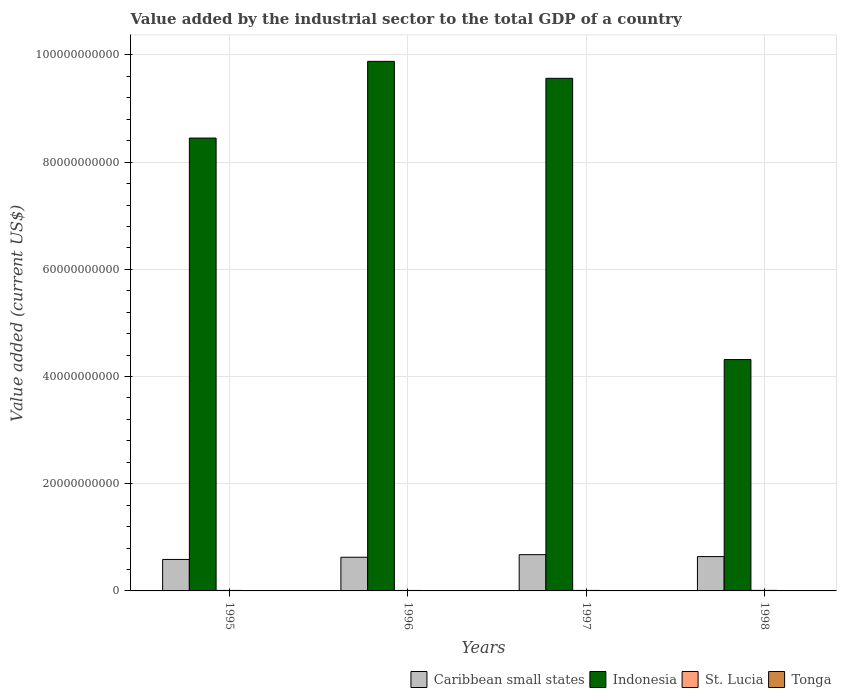Are the number of bars per tick equal to the number of legend labels?
Your response must be concise. Yes. How many bars are there on the 2nd tick from the left?
Make the answer very short. 4. How many bars are there on the 1st tick from the right?
Your answer should be compact. 4. What is the value added by the industrial sector to the total GDP in Indonesia in 1996?
Offer a very short reply. 9.88e+1. Across all years, what is the maximum value added by the industrial sector to the total GDP in Caribbean small states?
Keep it short and to the point. 6.76e+09. Across all years, what is the minimum value added by the industrial sector to the total GDP in St. Lucia?
Give a very brief answer. 9.03e+07. In which year was the value added by the industrial sector to the total GDP in Indonesia maximum?
Give a very brief answer. 1996. In which year was the value added by the industrial sector to the total GDP in Caribbean small states minimum?
Provide a succinct answer. 1995. What is the total value added by the industrial sector to the total GDP in Indonesia in the graph?
Ensure brevity in your answer.  3.22e+11. What is the difference between the value added by the industrial sector to the total GDP in Caribbean small states in 1996 and that in 1997?
Give a very brief answer. -4.80e+08. What is the difference between the value added by the industrial sector to the total GDP in Caribbean small states in 1996 and the value added by the industrial sector to the total GDP in St. Lucia in 1995?
Provide a short and direct response. 6.19e+09. What is the average value added by the industrial sector to the total GDP in St. Lucia per year?
Your answer should be compact. 9.35e+07. In the year 1998, what is the difference between the value added by the industrial sector to the total GDP in Indonesia and value added by the industrial sector to the total GDP in St. Lucia?
Your response must be concise. 4.31e+1. In how many years, is the value added by the industrial sector to the total GDP in Tonga greater than 20000000000 US$?
Ensure brevity in your answer.  0. What is the ratio of the value added by the industrial sector to the total GDP in St. Lucia in 1995 to that in 1997?
Offer a very short reply. 1.02. Is the value added by the industrial sector to the total GDP in Tonga in 1995 less than that in 1998?
Provide a succinct answer. No. Is the difference between the value added by the industrial sector to the total GDP in Indonesia in 1995 and 1998 greater than the difference between the value added by the industrial sector to the total GDP in St. Lucia in 1995 and 1998?
Your answer should be very brief. Yes. What is the difference between the highest and the second highest value added by the industrial sector to the total GDP in Caribbean small states?
Your answer should be very brief. 3.56e+08. What is the difference between the highest and the lowest value added by the industrial sector to the total GDP in Tonga?
Ensure brevity in your answer.  1.06e+07. Is it the case that in every year, the sum of the value added by the industrial sector to the total GDP in Tonga and value added by the industrial sector to the total GDP in Indonesia is greater than the sum of value added by the industrial sector to the total GDP in Caribbean small states and value added by the industrial sector to the total GDP in St. Lucia?
Your response must be concise. Yes. What does the 3rd bar from the left in 1996 represents?
Offer a very short reply. St. Lucia. What does the 1st bar from the right in 1995 represents?
Provide a short and direct response. Tonga. Is it the case that in every year, the sum of the value added by the industrial sector to the total GDP in Indonesia and value added by the industrial sector to the total GDP in Tonga is greater than the value added by the industrial sector to the total GDP in St. Lucia?
Ensure brevity in your answer.  Yes. How many bars are there?
Provide a succinct answer. 16. Are all the bars in the graph horizontal?
Ensure brevity in your answer.  No. What is the difference between two consecutive major ticks on the Y-axis?
Offer a very short reply. 2.00e+1. Does the graph contain grids?
Offer a terse response. Yes. How many legend labels are there?
Your answer should be very brief. 4. What is the title of the graph?
Provide a succinct answer. Value added by the industrial sector to the total GDP of a country. Does "Cabo Verde" appear as one of the legend labels in the graph?
Provide a succinct answer. No. What is the label or title of the X-axis?
Ensure brevity in your answer.  Years. What is the label or title of the Y-axis?
Provide a short and direct response. Value added (current US$). What is the Value added (current US$) of Caribbean small states in 1995?
Offer a terse response. 5.87e+09. What is the Value added (current US$) in Indonesia in 1995?
Your answer should be compact. 8.45e+1. What is the Value added (current US$) of St. Lucia in 1995?
Give a very brief answer. 9.26e+07. What is the Value added (current US$) of Tonga in 1995?
Offer a terse response. 3.95e+07. What is the Value added (current US$) of Caribbean small states in 1996?
Provide a succinct answer. 6.28e+09. What is the Value added (current US$) of Indonesia in 1996?
Offer a terse response. 9.88e+1. What is the Value added (current US$) of St. Lucia in 1996?
Your answer should be compact. 9.03e+07. What is the Value added (current US$) of Tonga in 1996?
Keep it short and to the point. 4.25e+07. What is the Value added (current US$) in Caribbean small states in 1997?
Your response must be concise. 6.76e+09. What is the Value added (current US$) in Indonesia in 1997?
Offer a very short reply. 9.56e+1. What is the Value added (current US$) in St. Lucia in 1997?
Give a very brief answer. 9.10e+07. What is the Value added (current US$) of Tonga in 1997?
Your response must be concise. 3.64e+07. What is the Value added (current US$) of Caribbean small states in 1998?
Offer a very short reply. 6.41e+09. What is the Value added (current US$) in Indonesia in 1998?
Give a very brief answer. 4.32e+1. What is the Value added (current US$) in St. Lucia in 1998?
Your answer should be very brief. 1.00e+08. What is the Value added (current US$) in Tonga in 1998?
Your answer should be compact. 3.18e+07. Across all years, what is the maximum Value added (current US$) of Caribbean small states?
Your answer should be compact. 6.76e+09. Across all years, what is the maximum Value added (current US$) in Indonesia?
Give a very brief answer. 9.88e+1. Across all years, what is the maximum Value added (current US$) of St. Lucia?
Provide a short and direct response. 1.00e+08. Across all years, what is the maximum Value added (current US$) of Tonga?
Your answer should be very brief. 4.25e+07. Across all years, what is the minimum Value added (current US$) in Caribbean small states?
Provide a succinct answer. 5.87e+09. Across all years, what is the minimum Value added (current US$) of Indonesia?
Ensure brevity in your answer.  4.32e+1. Across all years, what is the minimum Value added (current US$) in St. Lucia?
Give a very brief answer. 9.03e+07. Across all years, what is the minimum Value added (current US$) in Tonga?
Ensure brevity in your answer.  3.18e+07. What is the total Value added (current US$) in Caribbean small states in the graph?
Provide a short and direct response. 2.53e+1. What is the total Value added (current US$) in Indonesia in the graph?
Give a very brief answer. 3.22e+11. What is the total Value added (current US$) in St. Lucia in the graph?
Your response must be concise. 3.74e+08. What is the total Value added (current US$) in Tonga in the graph?
Keep it short and to the point. 1.50e+08. What is the difference between the Value added (current US$) in Caribbean small states in 1995 and that in 1996?
Your answer should be compact. -4.11e+08. What is the difference between the Value added (current US$) in Indonesia in 1995 and that in 1996?
Provide a succinct answer. -1.43e+1. What is the difference between the Value added (current US$) in St. Lucia in 1995 and that in 1996?
Provide a short and direct response. 2.36e+06. What is the difference between the Value added (current US$) in Tonga in 1995 and that in 1996?
Provide a short and direct response. -2.95e+06. What is the difference between the Value added (current US$) in Caribbean small states in 1995 and that in 1997?
Make the answer very short. -8.90e+08. What is the difference between the Value added (current US$) of Indonesia in 1995 and that in 1997?
Offer a terse response. -1.11e+1. What is the difference between the Value added (current US$) of St. Lucia in 1995 and that in 1997?
Provide a succinct answer. 1.59e+06. What is the difference between the Value added (current US$) in Tonga in 1995 and that in 1997?
Provide a succinct answer. 3.13e+06. What is the difference between the Value added (current US$) in Caribbean small states in 1995 and that in 1998?
Offer a very short reply. -5.34e+08. What is the difference between the Value added (current US$) in Indonesia in 1995 and that in 1998?
Offer a very short reply. 4.13e+1. What is the difference between the Value added (current US$) in St. Lucia in 1995 and that in 1998?
Keep it short and to the point. -7.36e+06. What is the difference between the Value added (current US$) in Tonga in 1995 and that in 1998?
Offer a terse response. 7.68e+06. What is the difference between the Value added (current US$) of Caribbean small states in 1996 and that in 1997?
Your answer should be very brief. -4.80e+08. What is the difference between the Value added (current US$) in Indonesia in 1996 and that in 1997?
Make the answer very short. 3.17e+09. What is the difference between the Value added (current US$) in St. Lucia in 1996 and that in 1997?
Make the answer very short. -7.78e+05. What is the difference between the Value added (current US$) of Tonga in 1996 and that in 1997?
Make the answer very short. 6.08e+06. What is the difference between the Value added (current US$) of Caribbean small states in 1996 and that in 1998?
Provide a succinct answer. -1.24e+08. What is the difference between the Value added (current US$) in Indonesia in 1996 and that in 1998?
Your answer should be compact. 5.56e+1. What is the difference between the Value added (current US$) in St. Lucia in 1996 and that in 1998?
Keep it short and to the point. -9.73e+06. What is the difference between the Value added (current US$) of Tonga in 1996 and that in 1998?
Offer a very short reply. 1.06e+07. What is the difference between the Value added (current US$) of Caribbean small states in 1997 and that in 1998?
Your response must be concise. 3.56e+08. What is the difference between the Value added (current US$) in Indonesia in 1997 and that in 1998?
Ensure brevity in your answer.  5.25e+1. What is the difference between the Value added (current US$) of St. Lucia in 1997 and that in 1998?
Ensure brevity in your answer.  -8.95e+06. What is the difference between the Value added (current US$) in Tonga in 1997 and that in 1998?
Provide a short and direct response. 4.55e+06. What is the difference between the Value added (current US$) in Caribbean small states in 1995 and the Value added (current US$) in Indonesia in 1996?
Give a very brief answer. -9.29e+1. What is the difference between the Value added (current US$) in Caribbean small states in 1995 and the Value added (current US$) in St. Lucia in 1996?
Keep it short and to the point. 5.78e+09. What is the difference between the Value added (current US$) of Caribbean small states in 1995 and the Value added (current US$) of Tonga in 1996?
Your answer should be compact. 5.83e+09. What is the difference between the Value added (current US$) of Indonesia in 1995 and the Value added (current US$) of St. Lucia in 1996?
Offer a very short reply. 8.44e+1. What is the difference between the Value added (current US$) of Indonesia in 1995 and the Value added (current US$) of Tonga in 1996?
Your answer should be very brief. 8.45e+1. What is the difference between the Value added (current US$) of St. Lucia in 1995 and the Value added (current US$) of Tonga in 1996?
Keep it short and to the point. 5.02e+07. What is the difference between the Value added (current US$) in Caribbean small states in 1995 and the Value added (current US$) in Indonesia in 1997?
Your response must be concise. -8.98e+1. What is the difference between the Value added (current US$) in Caribbean small states in 1995 and the Value added (current US$) in St. Lucia in 1997?
Your response must be concise. 5.78e+09. What is the difference between the Value added (current US$) in Caribbean small states in 1995 and the Value added (current US$) in Tonga in 1997?
Provide a short and direct response. 5.84e+09. What is the difference between the Value added (current US$) in Indonesia in 1995 and the Value added (current US$) in St. Lucia in 1997?
Keep it short and to the point. 8.44e+1. What is the difference between the Value added (current US$) in Indonesia in 1995 and the Value added (current US$) in Tonga in 1997?
Make the answer very short. 8.45e+1. What is the difference between the Value added (current US$) of St. Lucia in 1995 and the Value added (current US$) of Tonga in 1997?
Provide a succinct answer. 5.63e+07. What is the difference between the Value added (current US$) in Caribbean small states in 1995 and the Value added (current US$) in Indonesia in 1998?
Make the answer very short. -3.73e+1. What is the difference between the Value added (current US$) in Caribbean small states in 1995 and the Value added (current US$) in St. Lucia in 1998?
Provide a short and direct response. 5.77e+09. What is the difference between the Value added (current US$) in Caribbean small states in 1995 and the Value added (current US$) in Tonga in 1998?
Your answer should be compact. 5.84e+09. What is the difference between the Value added (current US$) in Indonesia in 1995 and the Value added (current US$) in St. Lucia in 1998?
Offer a terse response. 8.44e+1. What is the difference between the Value added (current US$) in Indonesia in 1995 and the Value added (current US$) in Tonga in 1998?
Your answer should be very brief. 8.45e+1. What is the difference between the Value added (current US$) of St. Lucia in 1995 and the Value added (current US$) of Tonga in 1998?
Provide a short and direct response. 6.08e+07. What is the difference between the Value added (current US$) of Caribbean small states in 1996 and the Value added (current US$) of Indonesia in 1997?
Your answer should be very brief. -8.94e+1. What is the difference between the Value added (current US$) of Caribbean small states in 1996 and the Value added (current US$) of St. Lucia in 1997?
Your answer should be very brief. 6.19e+09. What is the difference between the Value added (current US$) in Caribbean small states in 1996 and the Value added (current US$) in Tonga in 1997?
Your answer should be compact. 6.25e+09. What is the difference between the Value added (current US$) in Indonesia in 1996 and the Value added (current US$) in St. Lucia in 1997?
Your answer should be very brief. 9.87e+1. What is the difference between the Value added (current US$) in Indonesia in 1996 and the Value added (current US$) in Tonga in 1997?
Your answer should be compact. 9.88e+1. What is the difference between the Value added (current US$) of St. Lucia in 1996 and the Value added (current US$) of Tonga in 1997?
Make the answer very short. 5.39e+07. What is the difference between the Value added (current US$) in Caribbean small states in 1996 and the Value added (current US$) in Indonesia in 1998?
Give a very brief answer. -3.69e+1. What is the difference between the Value added (current US$) of Caribbean small states in 1996 and the Value added (current US$) of St. Lucia in 1998?
Keep it short and to the point. 6.18e+09. What is the difference between the Value added (current US$) in Caribbean small states in 1996 and the Value added (current US$) in Tonga in 1998?
Make the answer very short. 6.25e+09. What is the difference between the Value added (current US$) in Indonesia in 1996 and the Value added (current US$) in St. Lucia in 1998?
Make the answer very short. 9.87e+1. What is the difference between the Value added (current US$) in Indonesia in 1996 and the Value added (current US$) in Tonga in 1998?
Offer a terse response. 9.88e+1. What is the difference between the Value added (current US$) of St. Lucia in 1996 and the Value added (current US$) of Tonga in 1998?
Ensure brevity in your answer.  5.84e+07. What is the difference between the Value added (current US$) in Caribbean small states in 1997 and the Value added (current US$) in Indonesia in 1998?
Keep it short and to the point. -3.64e+1. What is the difference between the Value added (current US$) of Caribbean small states in 1997 and the Value added (current US$) of St. Lucia in 1998?
Keep it short and to the point. 6.66e+09. What is the difference between the Value added (current US$) in Caribbean small states in 1997 and the Value added (current US$) in Tonga in 1998?
Ensure brevity in your answer.  6.73e+09. What is the difference between the Value added (current US$) of Indonesia in 1997 and the Value added (current US$) of St. Lucia in 1998?
Provide a succinct answer. 9.55e+1. What is the difference between the Value added (current US$) in Indonesia in 1997 and the Value added (current US$) in Tonga in 1998?
Your response must be concise. 9.56e+1. What is the difference between the Value added (current US$) in St. Lucia in 1997 and the Value added (current US$) in Tonga in 1998?
Keep it short and to the point. 5.92e+07. What is the average Value added (current US$) of Caribbean small states per year?
Ensure brevity in your answer.  6.33e+09. What is the average Value added (current US$) in Indonesia per year?
Offer a very short reply. 8.05e+1. What is the average Value added (current US$) in St. Lucia per year?
Your answer should be very brief. 9.35e+07. What is the average Value added (current US$) in Tonga per year?
Provide a short and direct response. 3.75e+07. In the year 1995, what is the difference between the Value added (current US$) of Caribbean small states and Value added (current US$) of Indonesia?
Your answer should be compact. -7.86e+1. In the year 1995, what is the difference between the Value added (current US$) of Caribbean small states and Value added (current US$) of St. Lucia?
Your answer should be compact. 5.78e+09. In the year 1995, what is the difference between the Value added (current US$) of Caribbean small states and Value added (current US$) of Tonga?
Give a very brief answer. 5.83e+09. In the year 1995, what is the difference between the Value added (current US$) of Indonesia and Value added (current US$) of St. Lucia?
Give a very brief answer. 8.44e+1. In the year 1995, what is the difference between the Value added (current US$) of Indonesia and Value added (current US$) of Tonga?
Provide a succinct answer. 8.45e+1. In the year 1995, what is the difference between the Value added (current US$) in St. Lucia and Value added (current US$) in Tonga?
Your answer should be very brief. 5.31e+07. In the year 1996, what is the difference between the Value added (current US$) of Caribbean small states and Value added (current US$) of Indonesia?
Offer a terse response. -9.25e+1. In the year 1996, what is the difference between the Value added (current US$) of Caribbean small states and Value added (current US$) of St. Lucia?
Provide a short and direct response. 6.19e+09. In the year 1996, what is the difference between the Value added (current US$) in Caribbean small states and Value added (current US$) in Tonga?
Give a very brief answer. 6.24e+09. In the year 1996, what is the difference between the Value added (current US$) of Indonesia and Value added (current US$) of St. Lucia?
Provide a short and direct response. 9.87e+1. In the year 1996, what is the difference between the Value added (current US$) of Indonesia and Value added (current US$) of Tonga?
Give a very brief answer. 9.88e+1. In the year 1996, what is the difference between the Value added (current US$) of St. Lucia and Value added (current US$) of Tonga?
Keep it short and to the point. 4.78e+07. In the year 1997, what is the difference between the Value added (current US$) of Caribbean small states and Value added (current US$) of Indonesia?
Give a very brief answer. -8.89e+1. In the year 1997, what is the difference between the Value added (current US$) of Caribbean small states and Value added (current US$) of St. Lucia?
Make the answer very short. 6.67e+09. In the year 1997, what is the difference between the Value added (current US$) in Caribbean small states and Value added (current US$) in Tonga?
Keep it short and to the point. 6.73e+09. In the year 1997, what is the difference between the Value added (current US$) in Indonesia and Value added (current US$) in St. Lucia?
Keep it short and to the point. 9.55e+1. In the year 1997, what is the difference between the Value added (current US$) in Indonesia and Value added (current US$) in Tonga?
Make the answer very short. 9.56e+1. In the year 1997, what is the difference between the Value added (current US$) in St. Lucia and Value added (current US$) in Tonga?
Make the answer very short. 5.47e+07. In the year 1998, what is the difference between the Value added (current US$) of Caribbean small states and Value added (current US$) of Indonesia?
Your answer should be compact. -3.68e+1. In the year 1998, what is the difference between the Value added (current US$) in Caribbean small states and Value added (current US$) in St. Lucia?
Make the answer very short. 6.31e+09. In the year 1998, what is the difference between the Value added (current US$) of Caribbean small states and Value added (current US$) of Tonga?
Keep it short and to the point. 6.38e+09. In the year 1998, what is the difference between the Value added (current US$) of Indonesia and Value added (current US$) of St. Lucia?
Give a very brief answer. 4.31e+1. In the year 1998, what is the difference between the Value added (current US$) in Indonesia and Value added (current US$) in Tonga?
Your answer should be very brief. 4.31e+1. In the year 1998, what is the difference between the Value added (current US$) in St. Lucia and Value added (current US$) in Tonga?
Offer a terse response. 6.82e+07. What is the ratio of the Value added (current US$) of Caribbean small states in 1995 to that in 1996?
Offer a terse response. 0.93. What is the ratio of the Value added (current US$) of Indonesia in 1995 to that in 1996?
Give a very brief answer. 0.86. What is the ratio of the Value added (current US$) in St. Lucia in 1995 to that in 1996?
Provide a succinct answer. 1.03. What is the ratio of the Value added (current US$) in Tonga in 1995 to that in 1996?
Provide a succinct answer. 0.93. What is the ratio of the Value added (current US$) of Caribbean small states in 1995 to that in 1997?
Offer a terse response. 0.87. What is the ratio of the Value added (current US$) in Indonesia in 1995 to that in 1997?
Your response must be concise. 0.88. What is the ratio of the Value added (current US$) in St. Lucia in 1995 to that in 1997?
Your answer should be compact. 1.02. What is the ratio of the Value added (current US$) of Tonga in 1995 to that in 1997?
Offer a terse response. 1.09. What is the ratio of the Value added (current US$) of Caribbean small states in 1995 to that in 1998?
Give a very brief answer. 0.92. What is the ratio of the Value added (current US$) in Indonesia in 1995 to that in 1998?
Make the answer very short. 1.96. What is the ratio of the Value added (current US$) in St. Lucia in 1995 to that in 1998?
Your answer should be compact. 0.93. What is the ratio of the Value added (current US$) in Tonga in 1995 to that in 1998?
Your response must be concise. 1.24. What is the ratio of the Value added (current US$) of Caribbean small states in 1996 to that in 1997?
Your answer should be very brief. 0.93. What is the ratio of the Value added (current US$) in Indonesia in 1996 to that in 1997?
Offer a terse response. 1.03. What is the ratio of the Value added (current US$) in Tonga in 1996 to that in 1997?
Offer a terse response. 1.17. What is the ratio of the Value added (current US$) of Caribbean small states in 1996 to that in 1998?
Your answer should be very brief. 0.98. What is the ratio of the Value added (current US$) of Indonesia in 1996 to that in 1998?
Your answer should be compact. 2.29. What is the ratio of the Value added (current US$) in St. Lucia in 1996 to that in 1998?
Your answer should be very brief. 0.9. What is the ratio of the Value added (current US$) in Tonga in 1996 to that in 1998?
Keep it short and to the point. 1.33. What is the ratio of the Value added (current US$) in Caribbean small states in 1997 to that in 1998?
Give a very brief answer. 1.06. What is the ratio of the Value added (current US$) in Indonesia in 1997 to that in 1998?
Your answer should be compact. 2.22. What is the ratio of the Value added (current US$) of St. Lucia in 1997 to that in 1998?
Provide a succinct answer. 0.91. What is the ratio of the Value added (current US$) of Tonga in 1997 to that in 1998?
Ensure brevity in your answer.  1.14. What is the difference between the highest and the second highest Value added (current US$) of Caribbean small states?
Ensure brevity in your answer.  3.56e+08. What is the difference between the highest and the second highest Value added (current US$) in Indonesia?
Keep it short and to the point. 3.17e+09. What is the difference between the highest and the second highest Value added (current US$) of St. Lucia?
Offer a very short reply. 7.36e+06. What is the difference between the highest and the second highest Value added (current US$) of Tonga?
Provide a succinct answer. 2.95e+06. What is the difference between the highest and the lowest Value added (current US$) in Caribbean small states?
Keep it short and to the point. 8.90e+08. What is the difference between the highest and the lowest Value added (current US$) of Indonesia?
Provide a succinct answer. 5.56e+1. What is the difference between the highest and the lowest Value added (current US$) in St. Lucia?
Keep it short and to the point. 9.73e+06. What is the difference between the highest and the lowest Value added (current US$) of Tonga?
Make the answer very short. 1.06e+07. 